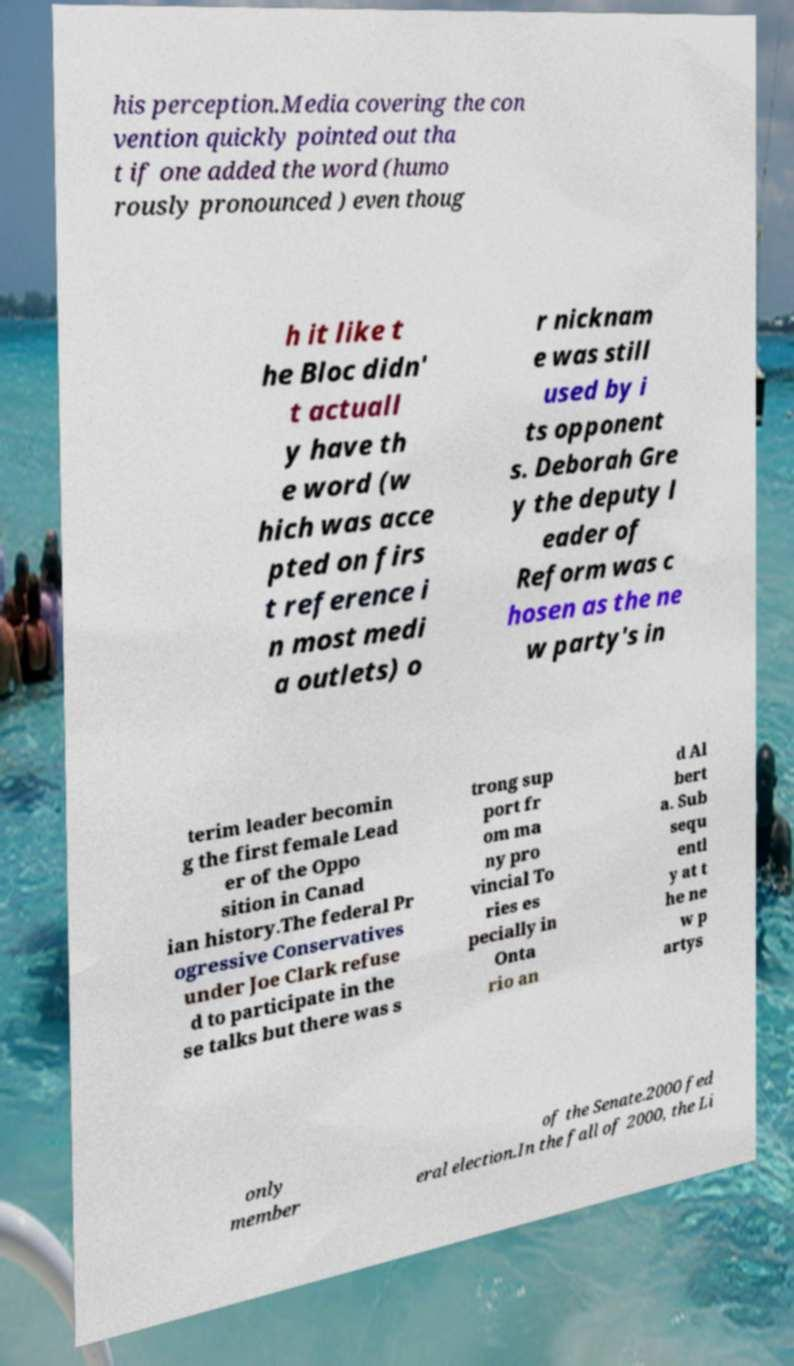Can you accurately transcribe the text from the provided image for me? his perception.Media covering the con vention quickly pointed out tha t if one added the word (humo rously pronounced ) even thoug h it like t he Bloc didn' t actuall y have th e word (w hich was acce pted on firs t reference i n most medi a outlets) o r nicknam e was still used by i ts opponent s. Deborah Gre y the deputy l eader of Reform was c hosen as the ne w party's in terim leader becomin g the first female Lead er of the Oppo sition in Canad ian history.The federal Pr ogressive Conservatives under Joe Clark refuse d to participate in the se talks but there was s trong sup port fr om ma ny pro vincial To ries es pecially in Onta rio an d Al bert a. Sub sequ entl y at t he ne w p artys only member of the Senate.2000 fed eral election.In the fall of 2000, the Li 